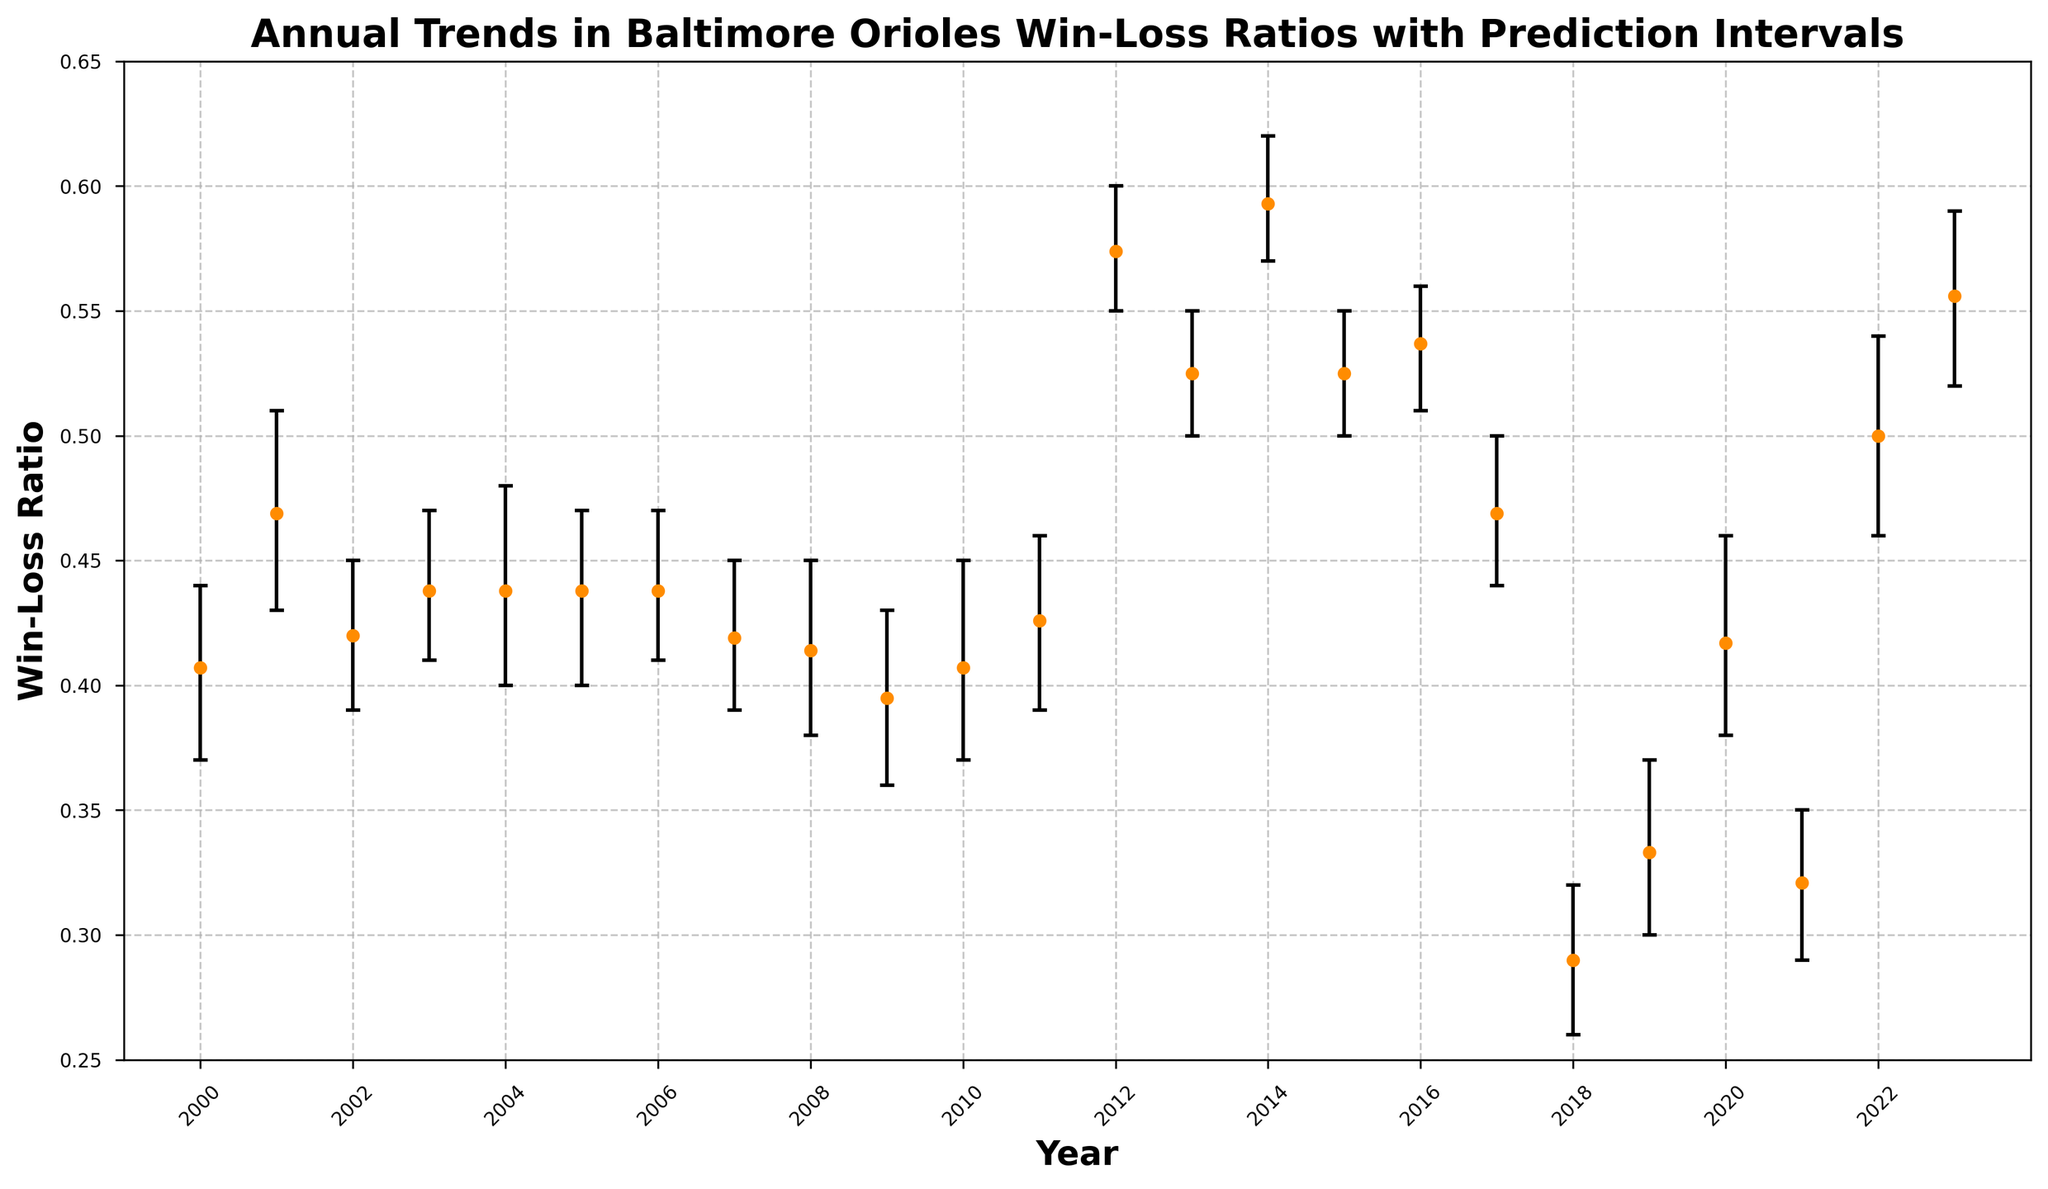Which year had the highest win-loss ratio? By observing the figure, identify the year with the highest data point for the win-loss ratio.
Answer: 2014 How did the win-loss ratios compare between 2018 and 2019? In the figure, compare the y-values (win-loss ratios) for the years 2018 and 2019.
Answer: 2019's ratio is higher What is the range of win-loss ratios for the year 2023? Find the upper and lower prediction intervals for 2023 on the figure and subtract the lower value from the upper value.
Answer: 0.07 Which year showed the largest improvement in win-loss ratio compared to the previous year? Calculate the difference between consecutive years' win-loss ratios and find the year with the greatest positive difference.
Answer: 2012 For the year 2000, is the win-loss ratio within the prediction interval? Check if the win-loss ratio data point for the year 2000 falls within the error bars (prediction interval).
Answer: Yes What is the average win-loss ratio from 2010 to 2015? Add the win-loss ratios from 2010 to 2015 and divide by the number of years (6).
Answer: 0.482 Identify years where the win-loss ratio decreased compared to the previous year. Observe the chart to identify years where the win-loss ratio point is lower than that of the previous year.
Answer: 2002, 2007, 2008, 2009, 2010, 2015, 2017, 2018, 2021 Which year had the largest prediction interval? Look for the year with the largest distance between the upper and lower bounds of the prediction interval bars.
Answer: 2001 How does the win-loss ratio trend in 2014 compare with the previous and following years? Analyze the win-loss ratios for 2013, 2014, and 2015 to determine if 2014 is significantly higher or lower compared to its neighboring years.
Answer: 2014 is significantly higher What is the median win-loss ratio over the entire period from 2000 to 2023? Sort the win-loss ratios from 2000 to 2023 and find the middle value.
Answer: 0.438 